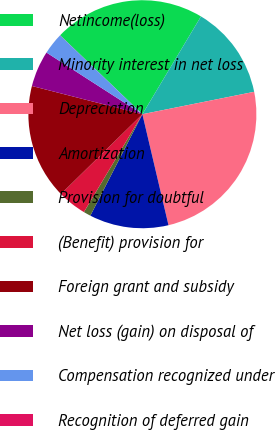<chart> <loc_0><loc_0><loc_500><loc_500><pie_chart><fcel>Netincome(loss)<fcel>Minority interest in net loss<fcel>Depreciation<fcel>Amortization<fcel>Provision for doubtful<fcel>(Benefit) provision for<fcel>Foreign grant and subsidy<fcel>Net loss (gain) on disposal of<fcel>Compensation recognized under<fcel>Recognition of deferred gain<nl><fcel>21.42%<fcel>13.26%<fcel>24.47%<fcel>11.22%<fcel>1.03%<fcel>4.09%<fcel>16.32%<fcel>5.11%<fcel>3.07%<fcel>0.01%<nl></chart> 